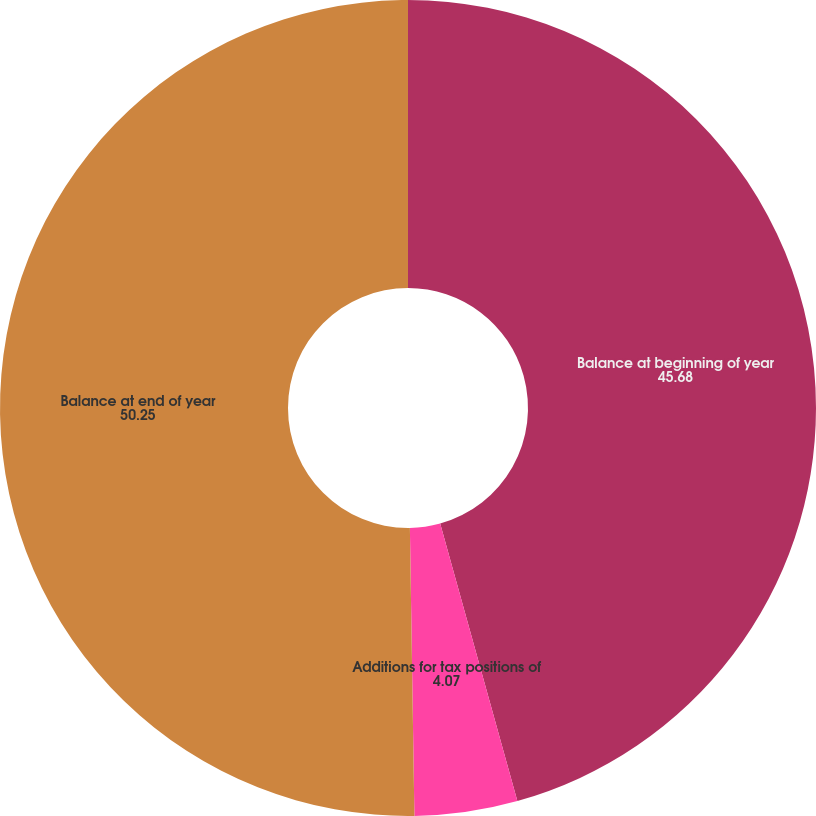Convert chart. <chart><loc_0><loc_0><loc_500><loc_500><pie_chart><fcel>Balance at beginning of year<fcel>Additions for tax positions of<fcel>Balance at end of year<nl><fcel>45.68%<fcel>4.07%<fcel>50.25%<nl></chart> 